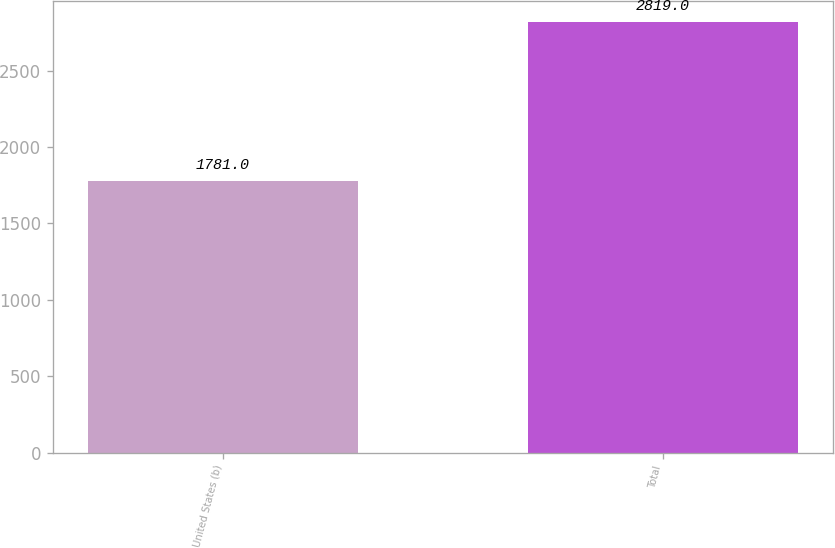Convert chart. <chart><loc_0><loc_0><loc_500><loc_500><bar_chart><fcel>United States (b)<fcel>Total<nl><fcel>1781<fcel>2819<nl></chart> 